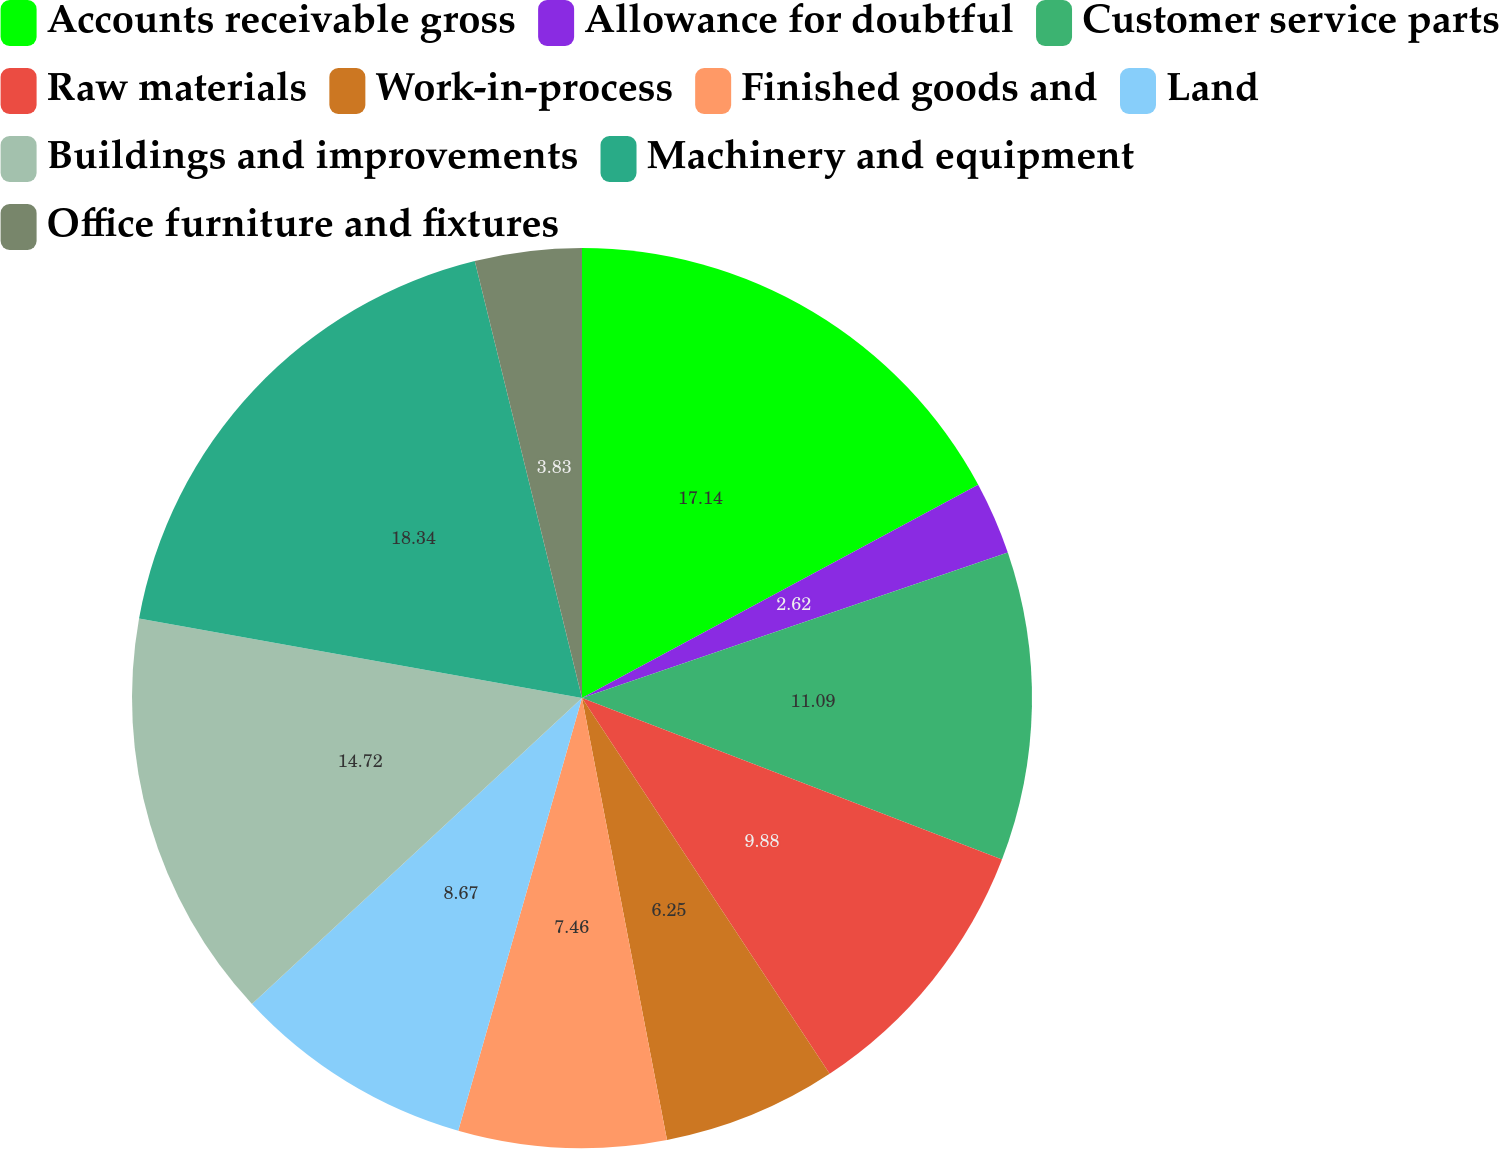Convert chart to OTSL. <chart><loc_0><loc_0><loc_500><loc_500><pie_chart><fcel>Accounts receivable gross<fcel>Allowance for doubtful<fcel>Customer service parts<fcel>Raw materials<fcel>Work-in-process<fcel>Finished goods and<fcel>Land<fcel>Buildings and improvements<fcel>Machinery and equipment<fcel>Office furniture and fixtures<nl><fcel>17.14%<fcel>2.62%<fcel>11.09%<fcel>9.88%<fcel>6.25%<fcel>7.46%<fcel>8.67%<fcel>14.72%<fcel>18.35%<fcel>3.83%<nl></chart> 